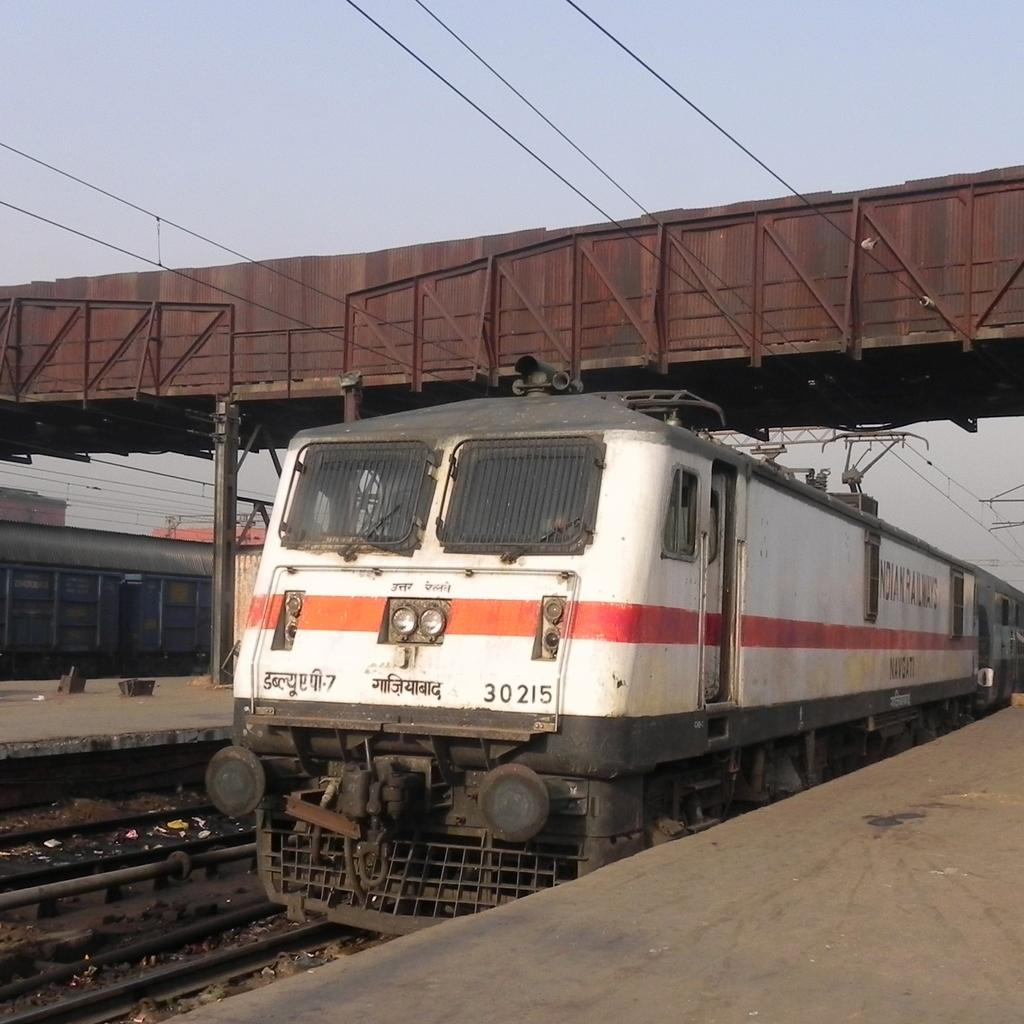<image>
Describe the image concisely. The number of the train shown on the tracks is 30215. 